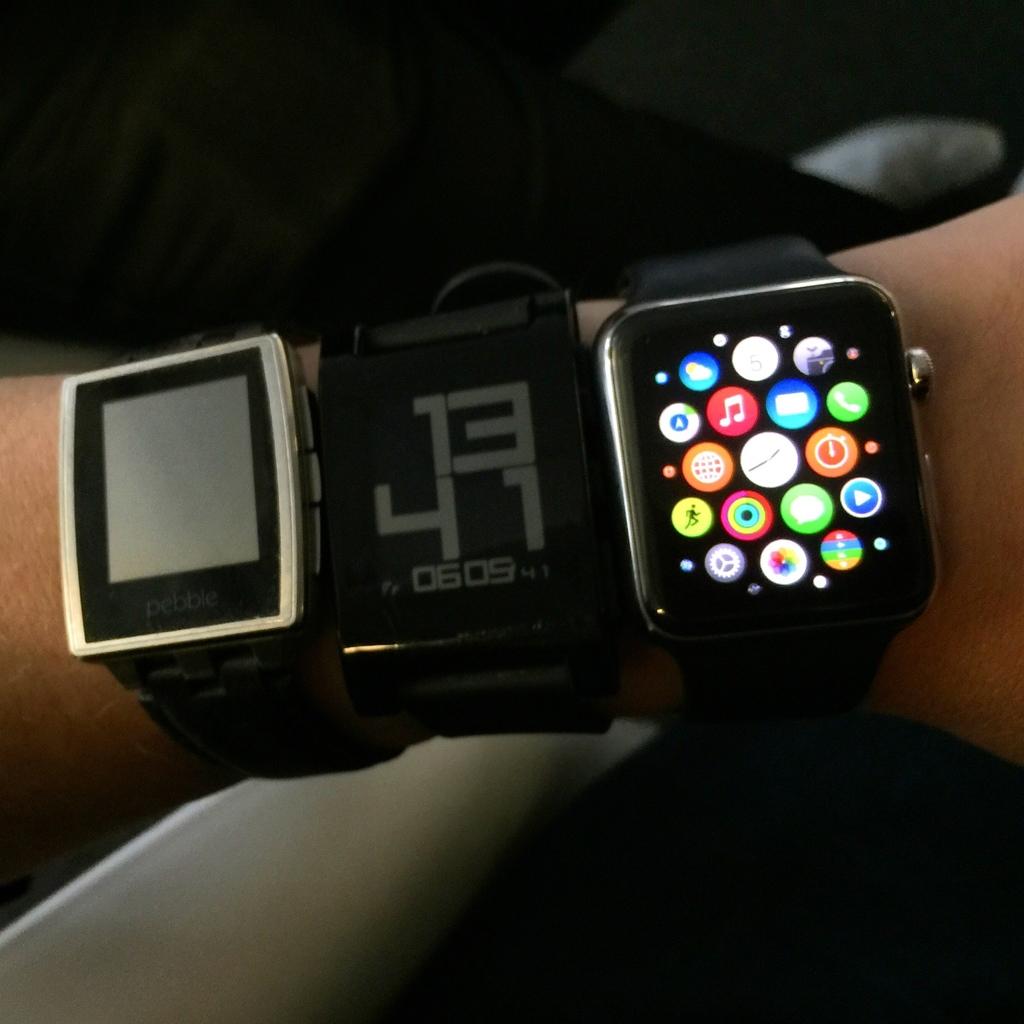What is one kind of smart watch shown?
Make the answer very short. Pebble. Which numbers are displayed in very large font on the watch?
Give a very brief answer. 1341. 